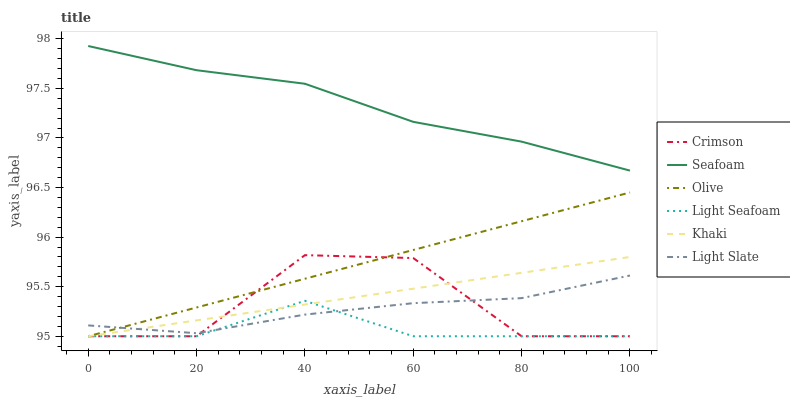Does Light Seafoam have the minimum area under the curve?
Answer yes or no. Yes. Does Seafoam have the maximum area under the curve?
Answer yes or no. Yes. Does Light Slate have the minimum area under the curve?
Answer yes or no. No. Does Light Slate have the maximum area under the curve?
Answer yes or no. No. Is Olive the smoothest?
Answer yes or no. Yes. Is Crimson the roughest?
Answer yes or no. Yes. Is Light Slate the smoothest?
Answer yes or no. No. Is Light Slate the roughest?
Answer yes or no. No. Does Khaki have the lowest value?
Answer yes or no. Yes. Does Light Slate have the lowest value?
Answer yes or no. No. Does Seafoam have the highest value?
Answer yes or no. Yes. Does Light Slate have the highest value?
Answer yes or no. No. Is Olive less than Seafoam?
Answer yes or no. Yes. Is Seafoam greater than Crimson?
Answer yes or no. Yes. Does Khaki intersect Light Slate?
Answer yes or no. Yes. Is Khaki less than Light Slate?
Answer yes or no. No. Is Khaki greater than Light Slate?
Answer yes or no. No. Does Olive intersect Seafoam?
Answer yes or no. No. 